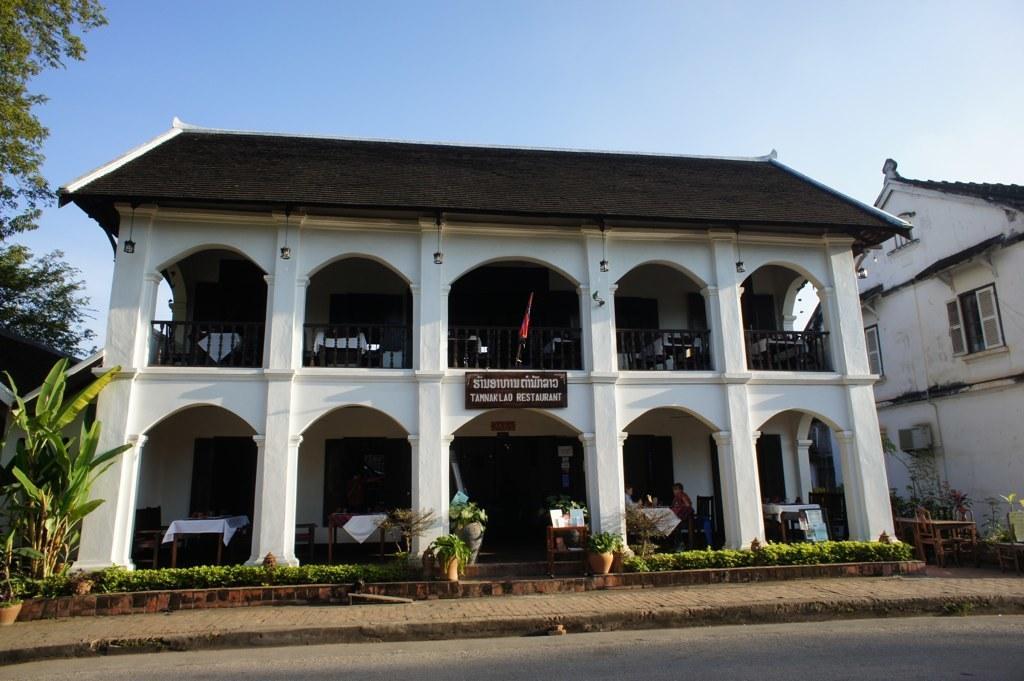In one or two sentences, can you explain what this image depicts? In this picture I can see there are two buildings and there is a road, there are few plants on the walkway, there are trees at left side. There is a building and it has tables, chairs and there is another building on right side and it has windows. The sky is clear. 